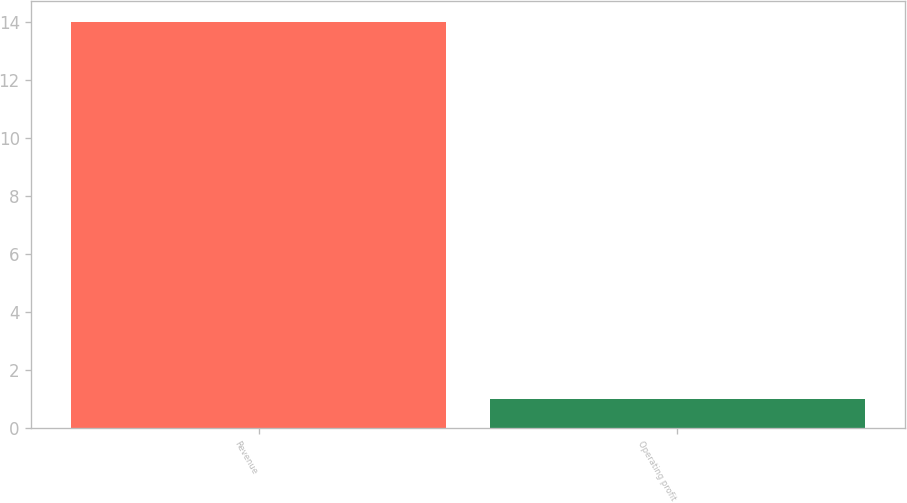Convert chart. <chart><loc_0><loc_0><loc_500><loc_500><bar_chart><fcel>Revenue<fcel>Operating profit<nl><fcel>14<fcel>1<nl></chart> 